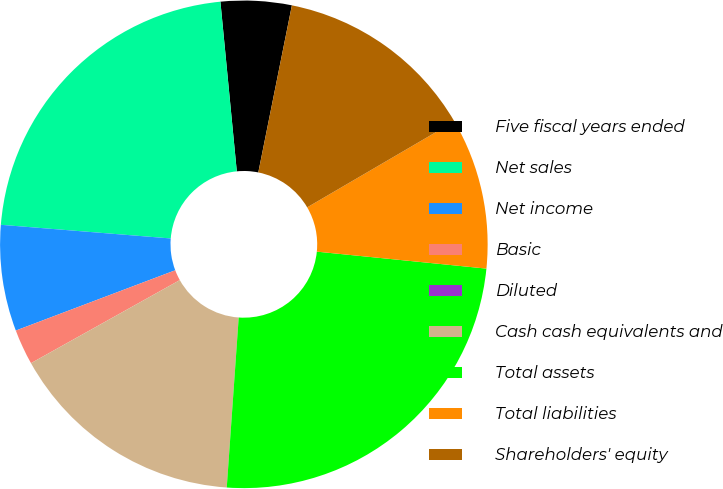Convert chart. <chart><loc_0><loc_0><loc_500><loc_500><pie_chart><fcel>Five fiscal years ended<fcel>Net sales<fcel>Net income<fcel>Basic<fcel>Diluted<fcel>Cash cash equivalents and<fcel>Total assets<fcel>Total liabilities<fcel>Shareholders' equity<nl><fcel>4.69%<fcel>22.19%<fcel>7.03%<fcel>2.35%<fcel>0.0%<fcel>15.78%<fcel>24.53%<fcel>10.0%<fcel>13.43%<nl></chart> 